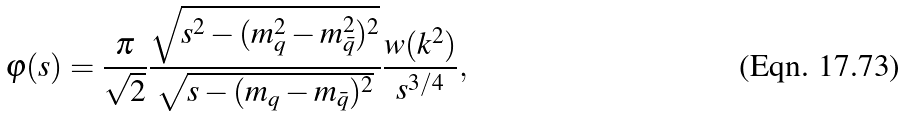Convert formula to latex. <formula><loc_0><loc_0><loc_500><loc_500>\varphi ( s ) = \frac { \pi } { \sqrt { 2 } } \frac { \sqrt { s ^ { 2 } - ( m _ { q } ^ { 2 } - m _ { \bar { q } } ^ { 2 } ) ^ { 2 } } } { \sqrt { s - ( m _ { q } - m _ { \bar { q } } ) ^ { 2 } } } \frac { w ( k ^ { 2 } ) } { s ^ { 3 / 4 } } ,</formula> 